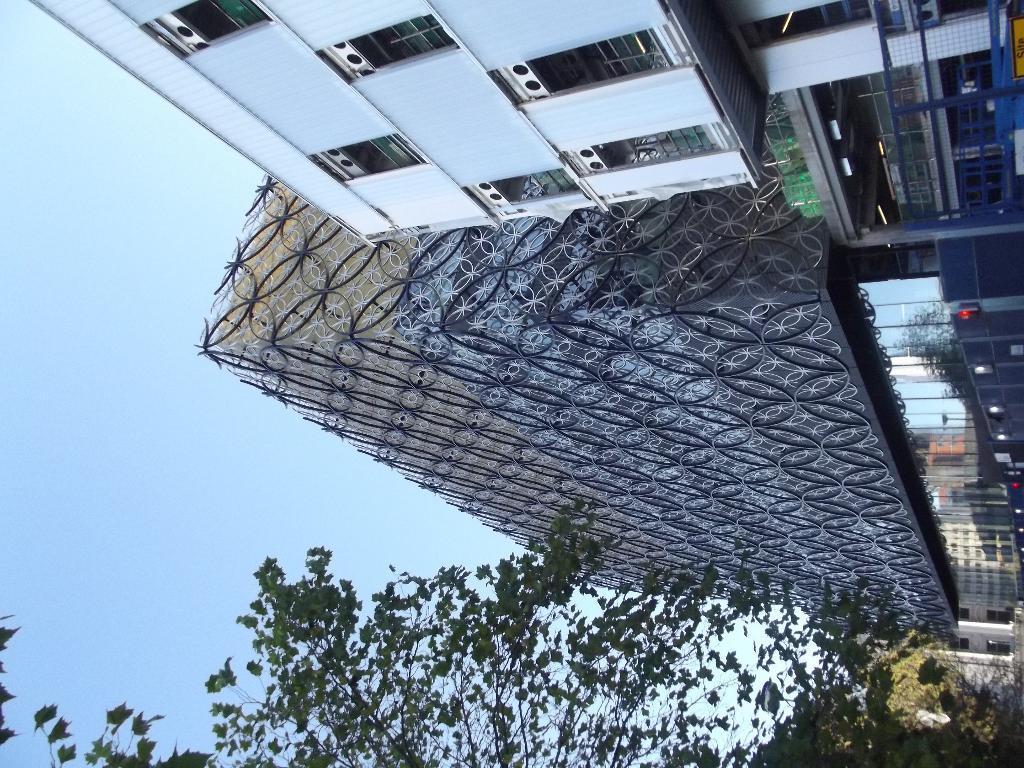Could you give a brief overview of what you see in this image? In this image we can see buildings, architecture, trees and blue sky. 